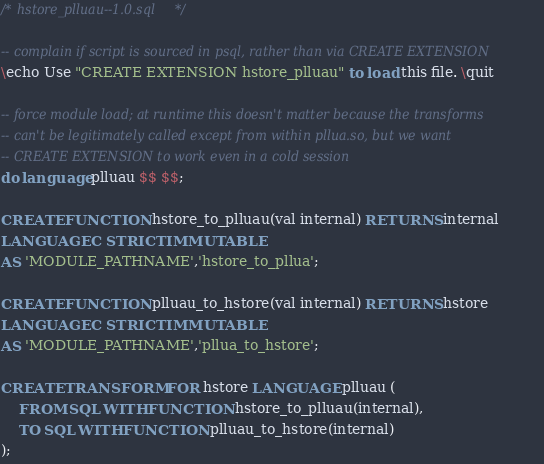Convert code to text. <code><loc_0><loc_0><loc_500><loc_500><_SQL_>/* hstore_plluau--1.0.sql */

-- complain if script is sourced in psql, rather than via CREATE EXTENSION
\echo Use "CREATE EXTENSION hstore_plluau" to load this file. \quit

-- force module load; at runtime this doesn't matter because the transforms
-- can't be legitimately called except from within pllua.so, but we want
-- CREATE EXTENSION to work even in a cold session
do language plluau $$ $$;

CREATE FUNCTION hstore_to_plluau(val internal) RETURNS internal
LANGUAGE C STRICT IMMUTABLE
AS 'MODULE_PATHNAME','hstore_to_pllua';

CREATE FUNCTION plluau_to_hstore(val internal) RETURNS hstore
LANGUAGE C STRICT IMMUTABLE
AS 'MODULE_PATHNAME','pllua_to_hstore';

CREATE TRANSFORM FOR hstore LANGUAGE plluau (
    FROM SQL WITH FUNCTION hstore_to_plluau(internal),
    TO SQL WITH FUNCTION plluau_to_hstore(internal)
);
</code> 